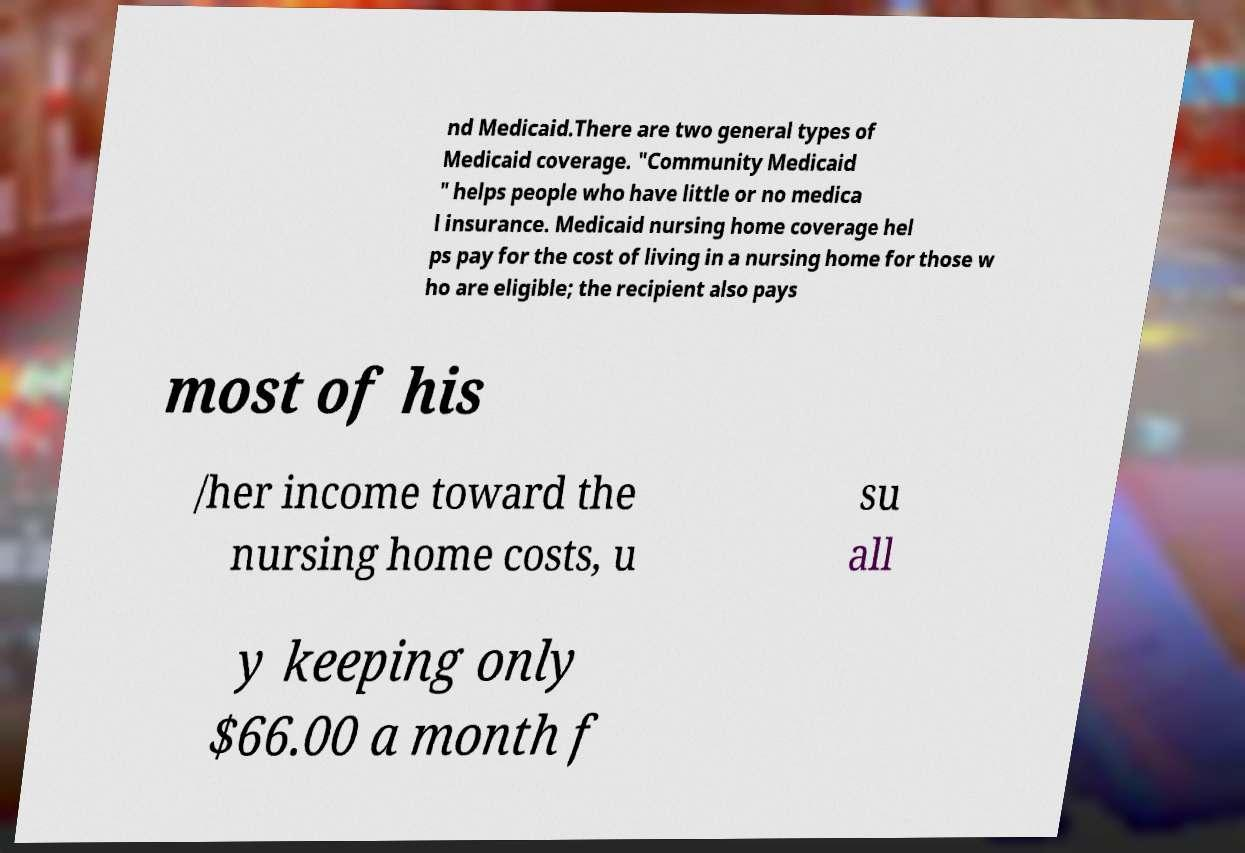For documentation purposes, I need the text within this image transcribed. Could you provide that? nd Medicaid.There are two general types of Medicaid coverage. "Community Medicaid " helps people who have little or no medica l insurance. Medicaid nursing home coverage hel ps pay for the cost of living in a nursing home for those w ho are eligible; the recipient also pays most of his /her income toward the nursing home costs, u su all y keeping only $66.00 a month f 